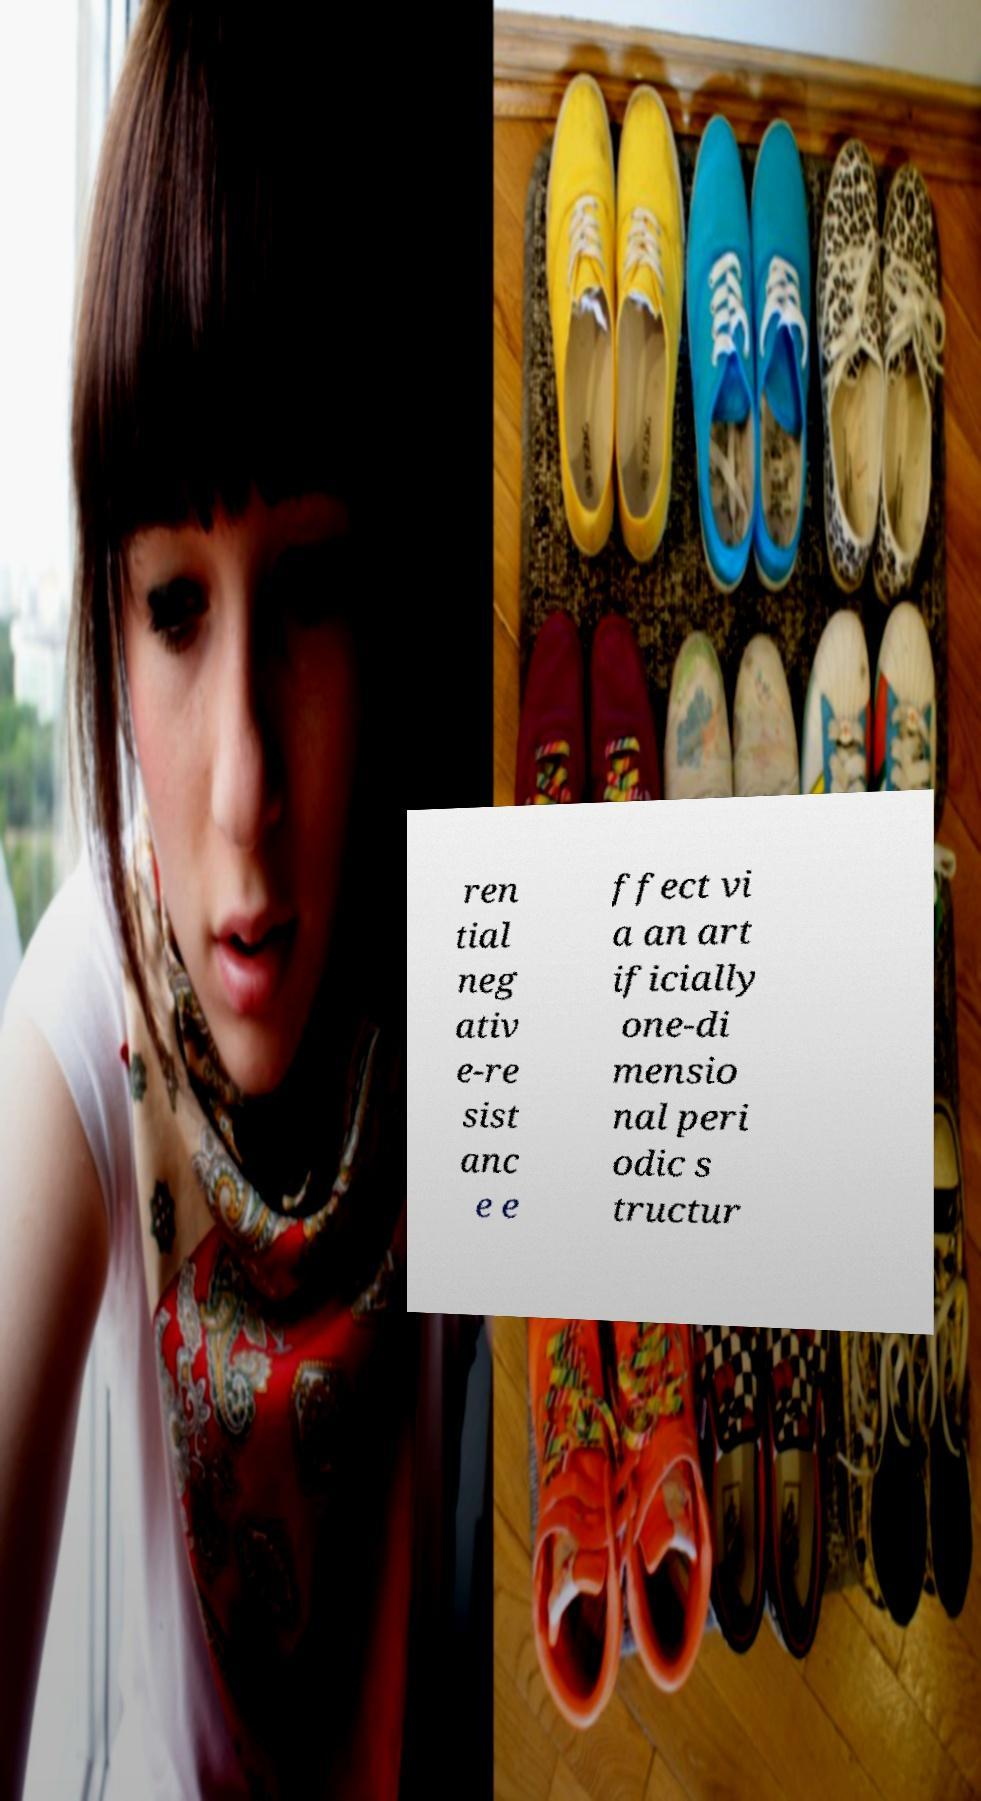Please read and relay the text visible in this image. What does it say? ren tial neg ativ e-re sist anc e e ffect vi a an art ificially one-di mensio nal peri odic s tructur 